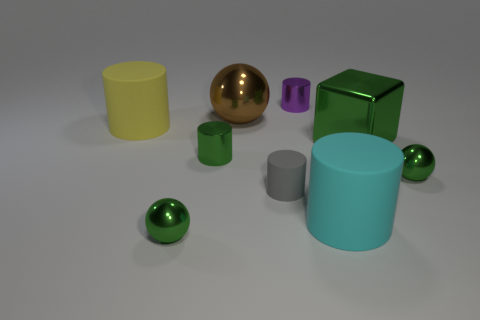Subtract all cyan cylinders. How many cylinders are left? 4 Subtract all gray cylinders. How many cylinders are left? 4 Subtract all brown cylinders. Subtract all brown spheres. How many cylinders are left? 5 Subtract all blocks. How many objects are left? 8 Add 4 small green metal cylinders. How many small green metal cylinders are left? 5 Add 2 tiny green metallic spheres. How many tiny green metallic spheres exist? 4 Subtract 1 green blocks. How many objects are left? 8 Subtract all metal cylinders. Subtract all small matte cylinders. How many objects are left? 6 